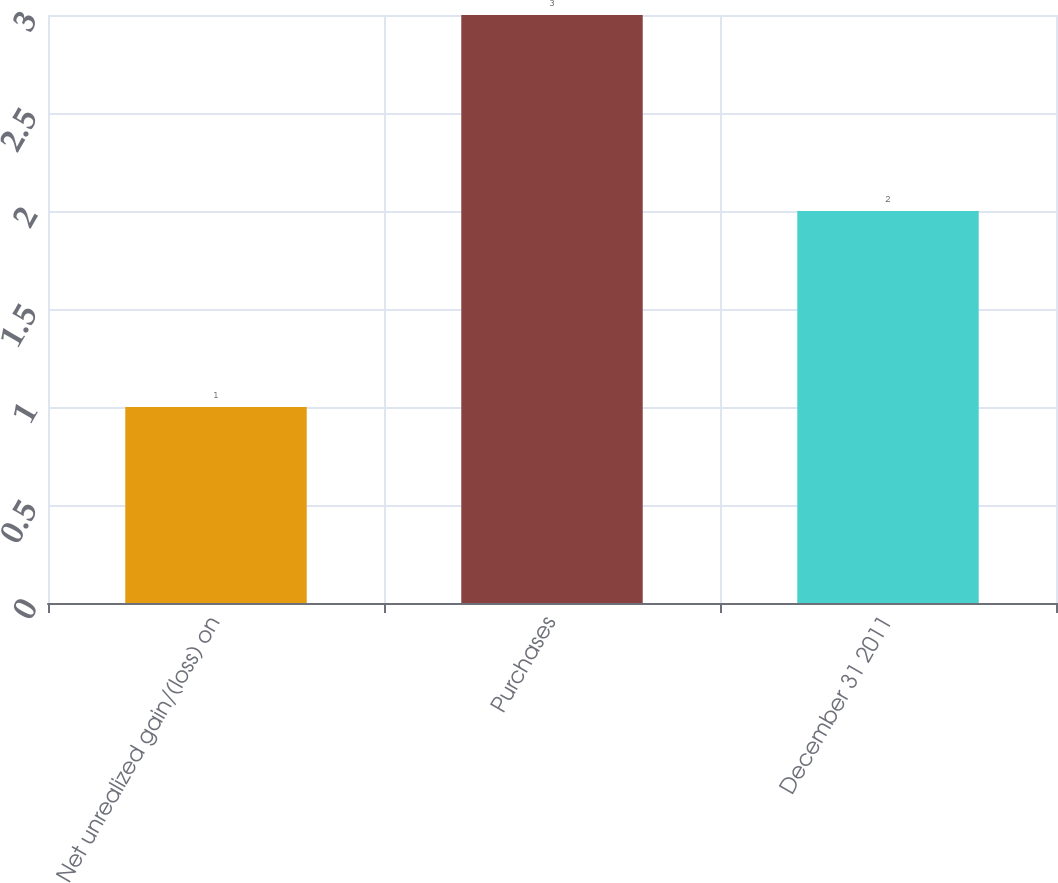<chart> <loc_0><loc_0><loc_500><loc_500><bar_chart><fcel>Net unrealized gain/(loss) on<fcel>Purchases<fcel>December 31 2011<nl><fcel>1<fcel>3<fcel>2<nl></chart> 